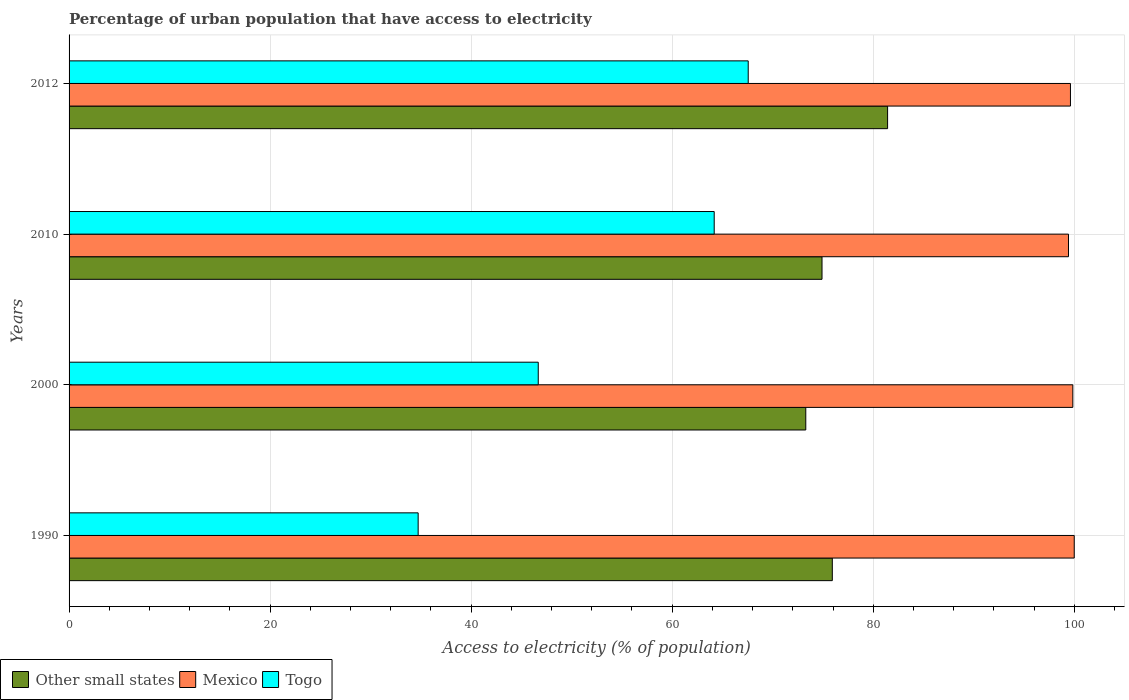Are the number of bars on each tick of the Y-axis equal?
Your answer should be compact. Yes. Across all years, what is the maximum percentage of urban population that have access to electricity in Other small states?
Your response must be concise. 81.43. Across all years, what is the minimum percentage of urban population that have access to electricity in Togo?
Your response must be concise. 34.73. In which year was the percentage of urban population that have access to electricity in Togo maximum?
Offer a very short reply. 2012. What is the total percentage of urban population that have access to electricity in Other small states in the graph?
Offer a terse response. 305.56. What is the difference between the percentage of urban population that have access to electricity in Togo in 1990 and that in 2010?
Your answer should be compact. -29.45. What is the difference between the percentage of urban population that have access to electricity in Togo in 1990 and the percentage of urban population that have access to electricity in Mexico in 2012?
Provide a short and direct response. -64.9. What is the average percentage of urban population that have access to electricity in Other small states per year?
Provide a succinct answer. 76.39. In the year 1990, what is the difference between the percentage of urban population that have access to electricity in Togo and percentage of urban population that have access to electricity in Other small states?
Ensure brevity in your answer.  -41.2. What is the ratio of the percentage of urban population that have access to electricity in Togo in 1990 to that in 2012?
Provide a short and direct response. 0.51. Is the difference between the percentage of urban population that have access to electricity in Togo in 2010 and 2012 greater than the difference between the percentage of urban population that have access to electricity in Other small states in 2010 and 2012?
Offer a terse response. Yes. What is the difference between the highest and the second highest percentage of urban population that have access to electricity in Mexico?
Offer a terse response. 0.14. What is the difference between the highest and the lowest percentage of urban population that have access to electricity in Mexico?
Offer a very short reply. 0.57. What does the 1st bar from the top in 2012 represents?
Offer a very short reply. Togo. Is it the case that in every year, the sum of the percentage of urban population that have access to electricity in Togo and percentage of urban population that have access to electricity in Other small states is greater than the percentage of urban population that have access to electricity in Mexico?
Keep it short and to the point. Yes. How many bars are there?
Make the answer very short. 12. Are all the bars in the graph horizontal?
Your answer should be compact. Yes. What is the difference between two consecutive major ticks on the X-axis?
Offer a very short reply. 20. Are the values on the major ticks of X-axis written in scientific E-notation?
Keep it short and to the point. No. Does the graph contain any zero values?
Ensure brevity in your answer.  No. Does the graph contain grids?
Ensure brevity in your answer.  Yes. How many legend labels are there?
Provide a succinct answer. 3. What is the title of the graph?
Offer a terse response. Percentage of urban population that have access to electricity. Does "Croatia" appear as one of the legend labels in the graph?
Offer a very short reply. No. What is the label or title of the X-axis?
Your answer should be compact. Access to electricity (% of population). What is the label or title of the Y-axis?
Ensure brevity in your answer.  Years. What is the Access to electricity (% of population) in Other small states in 1990?
Ensure brevity in your answer.  75.93. What is the Access to electricity (% of population) in Togo in 1990?
Make the answer very short. 34.73. What is the Access to electricity (% of population) of Other small states in 2000?
Offer a very short reply. 73.29. What is the Access to electricity (% of population) in Mexico in 2000?
Keep it short and to the point. 99.86. What is the Access to electricity (% of population) in Togo in 2000?
Offer a very short reply. 46.68. What is the Access to electricity (% of population) of Other small states in 2010?
Ensure brevity in your answer.  74.91. What is the Access to electricity (% of population) in Mexico in 2010?
Offer a very short reply. 99.43. What is the Access to electricity (% of population) of Togo in 2010?
Give a very brief answer. 64.18. What is the Access to electricity (% of population) in Other small states in 2012?
Offer a very short reply. 81.43. What is the Access to electricity (% of population) in Mexico in 2012?
Ensure brevity in your answer.  99.62. What is the Access to electricity (% of population) in Togo in 2012?
Offer a terse response. 67.57. Across all years, what is the maximum Access to electricity (% of population) of Other small states?
Offer a very short reply. 81.43. Across all years, what is the maximum Access to electricity (% of population) in Togo?
Make the answer very short. 67.57. Across all years, what is the minimum Access to electricity (% of population) of Other small states?
Keep it short and to the point. 73.29. Across all years, what is the minimum Access to electricity (% of population) of Mexico?
Offer a very short reply. 99.43. Across all years, what is the minimum Access to electricity (% of population) of Togo?
Keep it short and to the point. 34.73. What is the total Access to electricity (% of population) of Other small states in the graph?
Provide a short and direct response. 305.56. What is the total Access to electricity (% of population) of Mexico in the graph?
Keep it short and to the point. 398.91. What is the total Access to electricity (% of population) of Togo in the graph?
Your answer should be very brief. 213.15. What is the difference between the Access to electricity (% of population) in Other small states in 1990 and that in 2000?
Your answer should be very brief. 2.64. What is the difference between the Access to electricity (% of population) in Mexico in 1990 and that in 2000?
Your response must be concise. 0.14. What is the difference between the Access to electricity (% of population) in Togo in 1990 and that in 2000?
Offer a terse response. -11.95. What is the difference between the Access to electricity (% of population) of Other small states in 1990 and that in 2010?
Provide a succinct answer. 1.02. What is the difference between the Access to electricity (% of population) in Mexico in 1990 and that in 2010?
Your answer should be compact. 0.57. What is the difference between the Access to electricity (% of population) in Togo in 1990 and that in 2010?
Offer a very short reply. -29.45. What is the difference between the Access to electricity (% of population) in Other small states in 1990 and that in 2012?
Offer a terse response. -5.5. What is the difference between the Access to electricity (% of population) in Mexico in 1990 and that in 2012?
Offer a terse response. 0.38. What is the difference between the Access to electricity (% of population) in Togo in 1990 and that in 2012?
Offer a terse response. -32.84. What is the difference between the Access to electricity (% of population) in Other small states in 2000 and that in 2010?
Ensure brevity in your answer.  -1.62. What is the difference between the Access to electricity (% of population) of Mexico in 2000 and that in 2010?
Offer a very short reply. 0.43. What is the difference between the Access to electricity (% of population) in Togo in 2000 and that in 2010?
Your response must be concise. -17.51. What is the difference between the Access to electricity (% of population) of Other small states in 2000 and that in 2012?
Offer a terse response. -8.14. What is the difference between the Access to electricity (% of population) of Mexico in 2000 and that in 2012?
Give a very brief answer. 0.24. What is the difference between the Access to electricity (% of population) in Togo in 2000 and that in 2012?
Ensure brevity in your answer.  -20.89. What is the difference between the Access to electricity (% of population) of Other small states in 2010 and that in 2012?
Provide a short and direct response. -6.52. What is the difference between the Access to electricity (% of population) of Mexico in 2010 and that in 2012?
Offer a terse response. -0.2. What is the difference between the Access to electricity (% of population) of Togo in 2010 and that in 2012?
Your answer should be compact. -3.38. What is the difference between the Access to electricity (% of population) in Other small states in 1990 and the Access to electricity (% of population) in Mexico in 2000?
Keep it short and to the point. -23.93. What is the difference between the Access to electricity (% of population) in Other small states in 1990 and the Access to electricity (% of population) in Togo in 2000?
Give a very brief answer. 29.26. What is the difference between the Access to electricity (% of population) in Mexico in 1990 and the Access to electricity (% of population) in Togo in 2000?
Offer a very short reply. 53.32. What is the difference between the Access to electricity (% of population) in Other small states in 1990 and the Access to electricity (% of population) in Mexico in 2010?
Your answer should be very brief. -23.5. What is the difference between the Access to electricity (% of population) of Other small states in 1990 and the Access to electricity (% of population) of Togo in 2010?
Your answer should be compact. 11.75. What is the difference between the Access to electricity (% of population) of Mexico in 1990 and the Access to electricity (% of population) of Togo in 2010?
Give a very brief answer. 35.82. What is the difference between the Access to electricity (% of population) of Other small states in 1990 and the Access to electricity (% of population) of Mexico in 2012?
Give a very brief answer. -23.69. What is the difference between the Access to electricity (% of population) in Other small states in 1990 and the Access to electricity (% of population) in Togo in 2012?
Give a very brief answer. 8.37. What is the difference between the Access to electricity (% of population) of Mexico in 1990 and the Access to electricity (% of population) of Togo in 2012?
Offer a terse response. 32.43. What is the difference between the Access to electricity (% of population) of Other small states in 2000 and the Access to electricity (% of population) of Mexico in 2010?
Your answer should be very brief. -26.14. What is the difference between the Access to electricity (% of population) in Other small states in 2000 and the Access to electricity (% of population) in Togo in 2010?
Your answer should be compact. 9.11. What is the difference between the Access to electricity (% of population) of Mexico in 2000 and the Access to electricity (% of population) of Togo in 2010?
Offer a very short reply. 35.68. What is the difference between the Access to electricity (% of population) of Other small states in 2000 and the Access to electricity (% of population) of Mexico in 2012?
Make the answer very short. -26.33. What is the difference between the Access to electricity (% of population) of Other small states in 2000 and the Access to electricity (% of population) of Togo in 2012?
Make the answer very short. 5.73. What is the difference between the Access to electricity (% of population) of Mexico in 2000 and the Access to electricity (% of population) of Togo in 2012?
Ensure brevity in your answer.  32.29. What is the difference between the Access to electricity (% of population) of Other small states in 2010 and the Access to electricity (% of population) of Mexico in 2012?
Your response must be concise. -24.72. What is the difference between the Access to electricity (% of population) of Other small states in 2010 and the Access to electricity (% of population) of Togo in 2012?
Offer a terse response. 7.34. What is the difference between the Access to electricity (% of population) in Mexico in 2010 and the Access to electricity (% of population) in Togo in 2012?
Ensure brevity in your answer.  31.86. What is the average Access to electricity (% of population) of Other small states per year?
Give a very brief answer. 76.39. What is the average Access to electricity (% of population) of Mexico per year?
Offer a very short reply. 99.73. What is the average Access to electricity (% of population) of Togo per year?
Give a very brief answer. 53.29. In the year 1990, what is the difference between the Access to electricity (% of population) of Other small states and Access to electricity (% of population) of Mexico?
Make the answer very short. -24.07. In the year 1990, what is the difference between the Access to electricity (% of population) in Other small states and Access to electricity (% of population) in Togo?
Provide a succinct answer. 41.2. In the year 1990, what is the difference between the Access to electricity (% of population) in Mexico and Access to electricity (% of population) in Togo?
Your answer should be very brief. 65.27. In the year 2000, what is the difference between the Access to electricity (% of population) of Other small states and Access to electricity (% of population) of Mexico?
Keep it short and to the point. -26.57. In the year 2000, what is the difference between the Access to electricity (% of population) of Other small states and Access to electricity (% of population) of Togo?
Make the answer very short. 26.62. In the year 2000, what is the difference between the Access to electricity (% of population) of Mexico and Access to electricity (% of population) of Togo?
Offer a very short reply. 53.18. In the year 2010, what is the difference between the Access to electricity (% of population) of Other small states and Access to electricity (% of population) of Mexico?
Ensure brevity in your answer.  -24.52. In the year 2010, what is the difference between the Access to electricity (% of population) in Other small states and Access to electricity (% of population) in Togo?
Ensure brevity in your answer.  10.73. In the year 2010, what is the difference between the Access to electricity (% of population) in Mexico and Access to electricity (% of population) in Togo?
Provide a succinct answer. 35.25. In the year 2012, what is the difference between the Access to electricity (% of population) in Other small states and Access to electricity (% of population) in Mexico?
Offer a terse response. -18.19. In the year 2012, what is the difference between the Access to electricity (% of population) in Other small states and Access to electricity (% of population) in Togo?
Offer a terse response. 13.87. In the year 2012, what is the difference between the Access to electricity (% of population) of Mexico and Access to electricity (% of population) of Togo?
Ensure brevity in your answer.  32.06. What is the ratio of the Access to electricity (% of population) in Other small states in 1990 to that in 2000?
Provide a short and direct response. 1.04. What is the ratio of the Access to electricity (% of population) of Mexico in 1990 to that in 2000?
Your response must be concise. 1. What is the ratio of the Access to electricity (% of population) in Togo in 1990 to that in 2000?
Provide a short and direct response. 0.74. What is the ratio of the Access to electricity (% of population) of Other small states in 1990 to that in 2010?
Provide a succinct answer. 1.01. What is the ratio of the Access to electricity (% of population) in Mexico in 1990 to that in 2010?
Offer a terse response. 1.01. What is the ratio of the Access to electricity (% of population) of Togo in 1990 to that in 2010?
Your answer should be very brief. 0.54. What is the ratio of the Access to electricity (% of population) in Other small states in 1990 to that in 2012?
Your response must be concise. 0.93. What is the ratio of the Access to electricity (% of population) in Mexico in 1990 to that in 2012?
Offer a very short reply. 1. What is the ratio of the Access to electricity (% of population) of Togo in 1990 to that in 2012?
Make the answer very short. 0.51. What is the ratio of the Access to electricity (% of population) in Other small states in 2000 to that in 2010?
Keep it short and to the point. 0.98. What is the ratio of the Access to electricity (% of population) of Mexico in 2000 to that in 2010?
Offer a terse response. 1. What is the ratio of the Access to electricity (% of population) in Togo in 2000 to that in 2010?
Provide a succinct answer. 0.73. What is the ratio of the Access to electricity (% of population) in Other small states in 2000 to that in 2012?
Provide a short and direct response. 0.9. What is the ratio of the Access to electricity (% of population) in Mexico in 2000 to that in 2012?
Keep it short and to the point. 1. What is the ratio of the Access to electricity (% of population) in Togo in 2000 to that in 2012?
Your answer should be compact. 0.69. What is the ratio of the Access to electricity (% of population) of Other small states in 2010 to that in 2012?
Make the answer very short. 0.92. What is the ratio of the Access to electricity (% of population) in Mexico in 2010 to that in 2012?
Your response must be concise. 1. What is the ratio of the Access to electricity (% of population) in Togo in 2010 to that in 2012?
Give a very brief answer. 0.95. What is the difference between the highest and the second highest Access to electricity (% of population) in Other small states?
Give a very brief answer. 5.5. What is the difference between the highest and the second highest Access to electricity (% of population) of Mexico?
Provide a succinct answer. 0.14. What is the difference between the highest and the second highest Access to electricity (% of population) of Togo?
Keep it short and to the point. 3.38. What is the difference between the highest and the lowest Access to electricity (% of population) of Other small states?
Keep it short and to the point. 8.14. What is the difference between the highest and the lowest Access to electricity (% of population) in Mexico?
Your response must be concise. 0.57. What is the difference between the highest and the lowest Access to electricity (% of population) in Togo?
Your response must be concise. 32.84. 